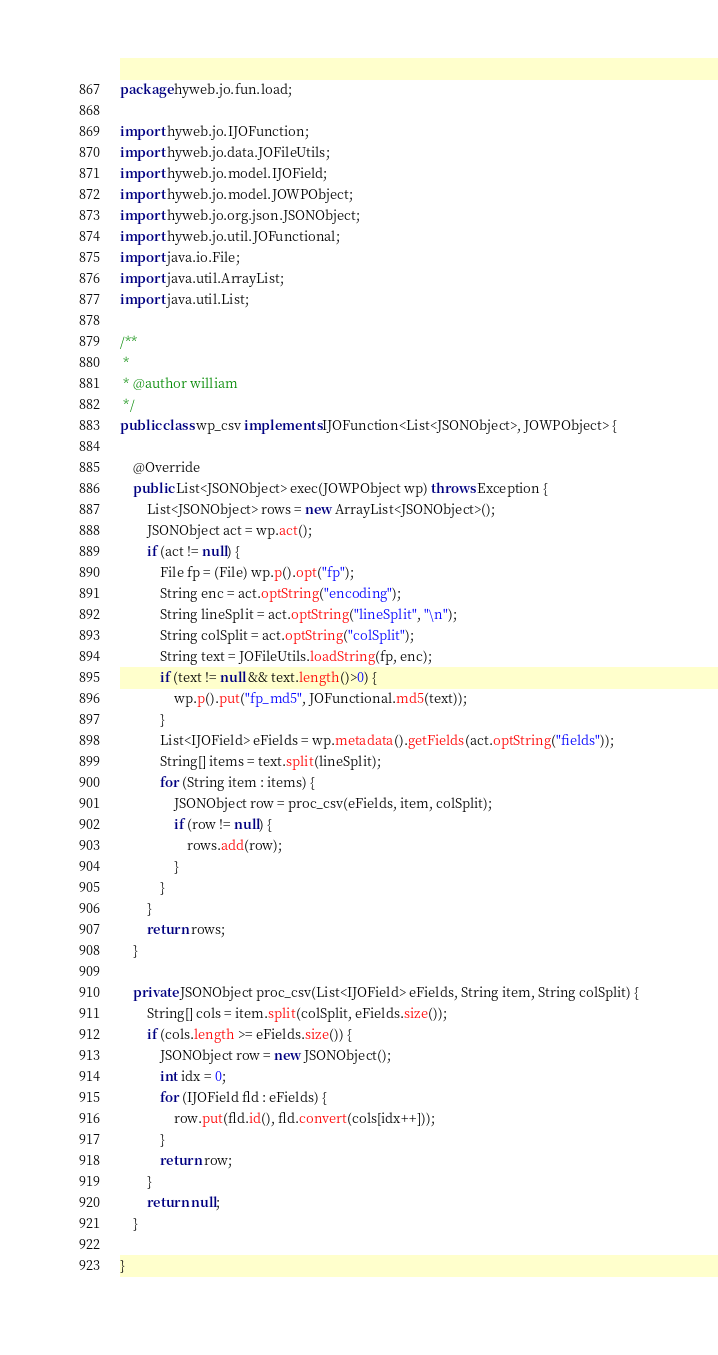<code> <loc_0><loc_0><loc_500><loc_500><_Java_>package hyweb.jo.fun.load;

import hyweb.jo.IJOFunction;
import hyweb.jo.data.JOFileUtils;
import hyweb.jo.model.IJOField;
import hyweb.jo.model.JOWPObject;
import hyweb.jo.org.json.JSONObject;
import hyweb.jo.util.JOFunctional;
import java.io.File;
import java.util.ArrayList;
import java.util.List;

/**
 *
 * @author william
 */
public class wp_csv implements IJOFunction<List<JSONObject>, JOWPObject> {

    @Override
    public List<JSONObject> exec(JOWPObject wp) throws Exception {
        List<JSONObject> rows = new ArrayList<JSONObject>();
        JSONObject act = wp.act();
        if (act != null) {
            File fp = (File) wp.p().opt("fp");
            String enc = act.optString("encoding");
            String lineSplit = act.optString("lineSplit", "\n");
            String colSplit = act.optString("colSplit");
            String text = JOFileUtils.loadString(fp, enc);
            if (text != null && text.length()>0) {
                wp.p().put("fp_md5", JOFunctional.md5(text));
            }
            List<IJOField> eFields = wp.metadata().getFields(act.optString("fields"));
            String[] items = text.split(lineSplit);
            for (String item : items) {
                JSONObject row = proc_csv(eFields, item, colSplit);
                if (row != null) {
                    rows.add(row);
                }
            }
        }
        return rows;
    }

    private JSONObject proc_csv(List<IJOField> eFields, String item, String colSplit) {
        String[] cols = item.split(colSplit, eFields.size());
        if (cols.length >= eFields.size()) {
            JSONObject row = new JSONObject();
            int idx = 0;
            for (IJOField fld : eFields) {
                row.put(fld.id(), fld.convert(cols[idx++]));
            }
            return row;
        }
        return null;
    }

}
</code> 